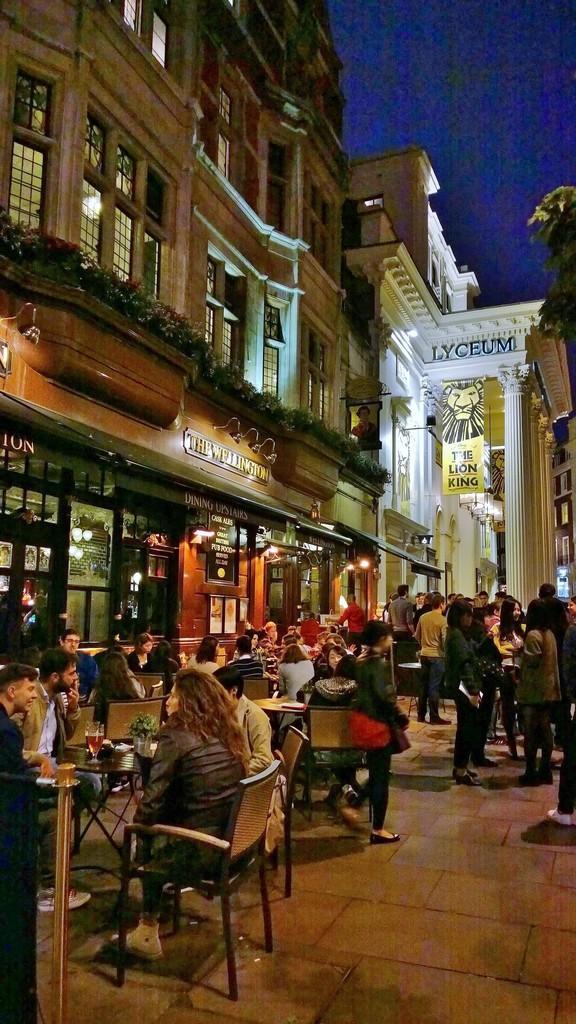Describe this image in one or two sentences. In the picture there are lot of people sitting and some of the people are standing , it looks like some restaurant, open area restaurant beside them there is a restaurant and upside the restaurant there is a big building in the background there are trees , another building and a sky. 